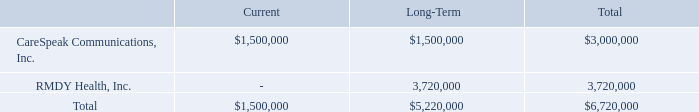NOTE 9 – CONTINGENT PURCHASE PRICE
Our purchase of CareSpeak Communications contains a contingent element that will be paid only if the Company achieves certain patient engagement revenues in 2019 and 2020. The total contingent payment may be up to $3.0 million. The target patient engagement revenues were achieved in 2019 and are expected to be achieved in 2020. The calculated fair value of the contingent payment was $2,365,000 at December 31, 2018 and $3,000,000 at December 31, 2019.
Our purchase of RMDY Health, Inc. also contains a contingent element that will be paid only if the Company achieves certain revenues in 2020 and 2021 related to the RMDY business. The total contingent payment may be up to $30.0 million. The minimum payment is $1.0 million in each of the two years. The calculated fair value of the contingent payment was $3,720,000 at December 31, 2019. We determined the fair value of the Contingent Purchase Price Payable at December 31, 2019 using a Geometric-Brownian motion analysis of the expected revenue and resulting earnout payment using inputs that include the spot price, a risk free rate of return of 1.4%, a term of 2 years, and volatility of 40%. Changes in the inputs could result in a different fair value measurement.
The total fair value of contingent purchase price payable at December 31, 2019 is as follows.
How much is the total contingent payment for the purchase of CareSpeak Communications? Up to $3.0 million. How did the company determine the fair value of the Contingent Purchase Price Payable on December 31, 2019? Using a geometric-brownian motion analysis of the expected revenue and resulting earnout payment using inputs that include the spot price, a risk free rate of return of 1.4%, a term of 2 years, and volatility of 40%. What is the total current fair value of contingent purchase price payable on December 31, 2019? $1,500,000. What is the proportion of total long-term fair value of contingent purchase price payable over total fair value of contingent purchase price payable? 5,220,000/6,720,000 
Answer: 0.78. What is the ratio of total fair value of the contingent payment in 2018 to 2019? 2,365,000/3,000,000 
Answer: 0.79. What is the percentage change in the total fair value of the contingent payment in 2019 compared to 2018?
Answer scale should be: percent. (3,000,000-2,365,000)/2,365,000 
Answer: 26.85. 